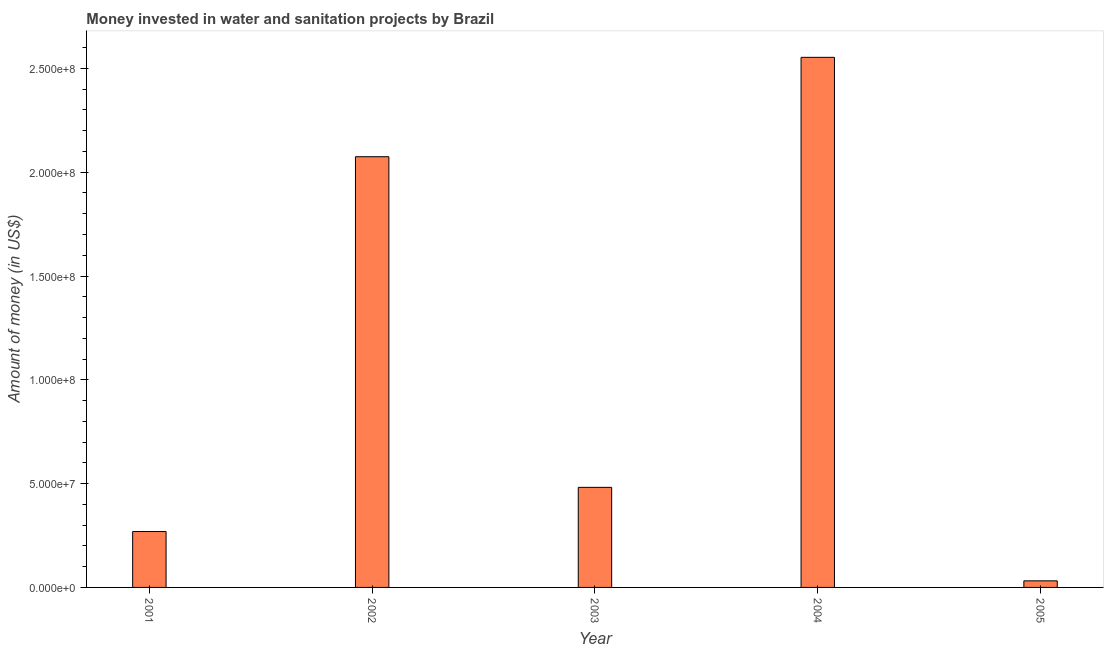Does the graph contain grids?
Your response must be concise. No. What is the title of the graph?
Provide a succinct answer. Money invested in water and sanitation projects by Brazil. What is the label or title of the Y-axis?
Your answer should be compact. Amount of money (in US$). What is the investment in 2004?
Provide a succinct answer. 2.55e+08. Across all years, what is the maximum investment?
Offer a very short reply. 2.55e+08. Across all years, what is the minimum investment?
Your answer should be very brief. 3.16e+06. What is the sum of the investment?
Your answer should be compact. 5.41e+08. What is the difference between the investment in 2001 and 2003?
Offer a very short reply. -2.13e+07. What is the average investment per year?
Offer a terse response. 1.08e+08. What is the median investment?
Offer a terse response. 4.82e+07. In how many years, is the investment greater than 230000000 US$?
Your answer should be compact. 1. What is the ratio of the investment in 2003 to that in 2005?
Provide a short and direct response. 15.23. Is the investment in 2001 less than that in 2005?
Your answer should be compact. No. Is the difference between the investment in 2002 and 2003 greater than the difference between any two years?
Offer a terse response. No. What is the difference between the highest and the second highest investment?
Keep it short and to the point. 4.79e+07. What is the difference between the highest and the lowest investment?
Give a very brief answer. 2.52e+08. What is the difference between two consecutive major ticks on the Y-axis?
Your answer should be very brief. 5.00e+07. What is the Amount of money (in US$) in 2001?
Provide a short and direct response. 2.69e+07. What is the Amount of money (in US$) of 2002?
Make the answer very short. 2.07e+08. What is the Amount of money (in US$) of 2003?
Your answer should be very brief. 4.82e+07. What is the Amount of money (in US$) of 2004?
Your answer should be compact. 2.55e+08. What is the Amount of money (in US$) in 2005?
Keep it short and to the point. 3.16e+06. What is the difference between the Amount of money (in US$) in 2001 and 2002?
Keep it short and to the point. -1.81e+08. What is the difference between the Amount of money (in US$) in 2001 and 2003?
Give a very brief answer. -2.13e+07. What is the difference between the Amount of money (in US$) in 2001 and 2004?
Offer a terse response. -2.28e+08. What is the difference between the Amount of money (in US$) in 2001 and 2005?
Provide a short and direct response. 2.38e+07. What is the difference between the Amount of money (in US$) in 2002 and 2003?
Make the answer very short. 1.59e+08. What is the difference between the Amount of money (in US$) in 2002 and 2004?
Your answer should be compact. -4.79e+07. What is the difference between the Amount of money (in US$) in 2002 and 2005?
Give a very brief answer. 2.04e+08. What is the difference between the Amount of money (in US$) in 2003 and 2004?
Your response must be concise. -2.07e+08. What is the difference between the Amount of money (in US$) in 2003 and 2005?
Your answer should be compact. 4.50e+07. What is the difference between the Amount of money (in US$) in 2004 and 2005?
Give a very brief answer. 2.52e+08. What is the ratio of the Amount of money (in US$) in 2001 to that in 2002?
Provide a succinct answer. 0.13. What is the ratio of the Amount of money (in US$) in 2001 to that in 2003?
Your answer should be very brief. 0.56. What is the ratio of the Amount of money (in US$) in 2001 to that in 2004?
Keep it short and to the point. 0.1. What is the ratio of the Amount of money (in US$) in 2001 to that in 2005?
Give a very brief answer. 8.51. What is the ratio of the Amount of money (in US$) in 2002 to that in 2003?
Keep it short and to the point. 4.3. What is the ratio of the Amount of money (in US$) in 2002 to that in 2004?
Your response must be concise. 0.81. What is the ratio of the Amount of money (in US$) in 2002 to that in 2005?
Ensure brevity in your answer.  65.57. What is the ratio of the Amount of money (in US$) in 2003 to that in 2004?
Your answer should be very brief. 0.19. What is the ratio of the Amount of money (in US$) in 2003 to that in 2005?
Provide a short and direct response. 15.23. What is the ratio of the Amount of money (in US$) in 2004 to that in 2005?
Keep it short and to the point. 80.7. 